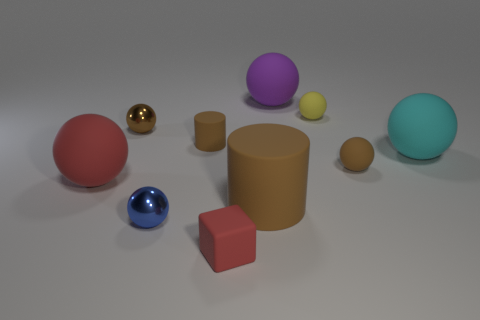Subtract all red rubber spheres. How many spheres are left? 6 Subtract all purple balls. How many balls are left? 6 Subtract 2 balls. How many balls are left? 5 Subtract all cyan balls. Subtract all yellow cylinders. How many balls are left? 6 Subtract all cylinders. How many objects are left? 8 Add 8 brown metallic balls. How many brown metallic balls exist? 9 Subtract 0 red cylinders. How many objects are left? 10 Subtract all big yellow matte balls. Subtract all yellow rubber spheres. How many objects are left? 9 Add 4 cylinders. How many cylinders are left? 6 